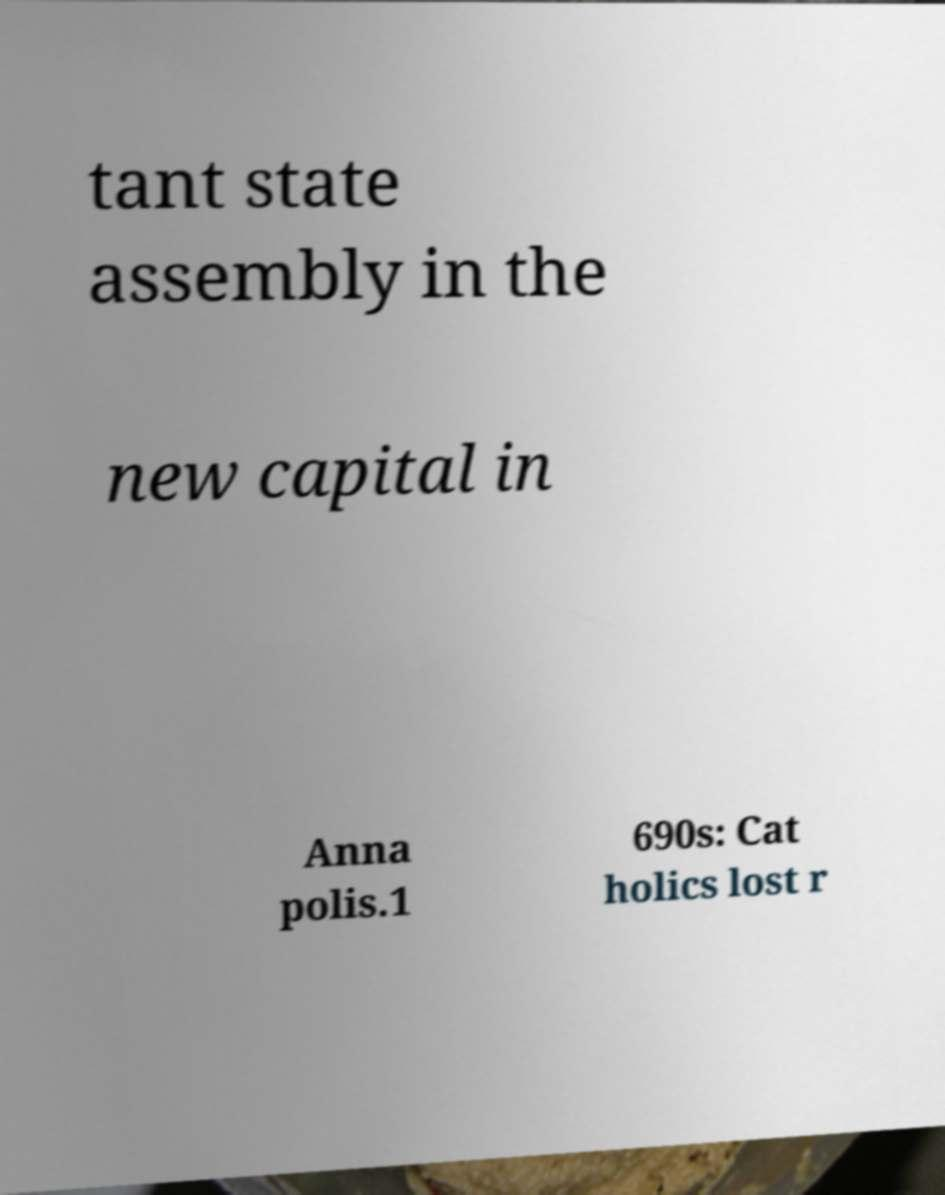For documentation purposes, I need the text within this image transcribed. Could you provide that? tant state assembly in the new capital in Anna polis.1 690s: Cat holics lost r 